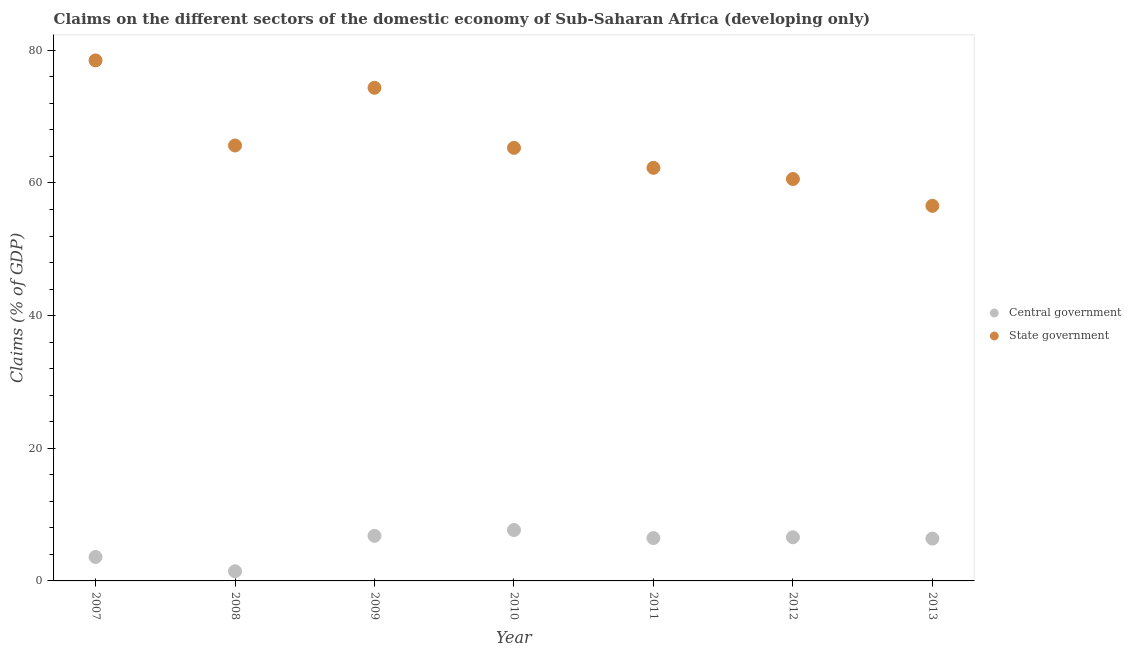What is the claims on central government in 2010?
Provide a succinct answer. 7.68. Across all years, what is the maximum claims on central government?
Ensure brevity in your answer.  7.68. Across all years, what is the minimum claims on state government?
Offer a very short reply. 56.56. In which year was the claims on central government minimum?
Offer a very short reply. 2008. What is the total claims on state government in the graph?
Make the answer very short. 463.22. What is the difference between the claims on central government in 2009 and that in 2012?
Your answer should be compact. 0.21. What is the difference between the claims on state government in 2007 and the claims on central government in 2008?
Ensure brevity in your answer.  77.03. What is the average claims on central government per year?
Offer a terse response. 5.57. In the year 2010, what is the difference between the claims on central government and claims on state government?
Provide a succinct answer. -57.62. In how many years, is the claims on state government greater than 20 %?
Provide a short and direct response. 7. What is the ratio of the claims on central government in 2008 to that in 2009?
Provide a short and direct response. 0.21. Is the claims on state government in 2009 less than that in 2013?
Give a very brief answer. No. What is the difference between the highest and the second highest claims on state government?
Give a very brief answer. 4.13. What is the difference between the highest and the lowest claims on central government?
Make the answer very short. 6.22. In how many years, is the claims on central government greater than the average claims on central government taken over all years?
Offer a terse response. 5. Is the sum of the claims on state government in 2008 and 2012 greater than the maximum claims on central government across all years?
Offer a very short reply. Yes. Is the claims on state government strictly less than the claims on central government over the years?
Provide a succinct answer. No. How many dotlines are there?
Offer a very short reply. 2. How many years are there in the graph?
Give a very brief answer. 7. Are the values on the major ticks of Y-axis written in scientific E-notation?
Keep it short and to the point. No. Does the graph contain any zero values?
Keep it short and to the point. No. Where does the legend appear in the graph?
Your response must be concise. Center right. How are the legend labels stacked?
Offer a very short reply. Vertical. What is the title of the graph?
Your answer should be very brief. Claims on the different sectors of the domestic economy of Sub-Saharan Africa (developing only). What is the label or title of the X-axis?
Provide a short and direct response. Year. What is the label or title of the Y-axis?
Offer a very short reply. Claims (% of GDP). What is the Claims (% of GDP) in Central government in 2007?
Provide a succinct answer. 3.61. What is the Claims (% of GDP) in State government in 2007?
Make the answer very short. 78.48. What is the Claims (% of GDP) of Central government in 2008?
Provide a short and direct response. 1.46. What is the Claims (% of GDP) in State government in 2008?
Give a very brief answer. 65.65. What is the Claims (% of GDP) in Central government in 2009?
Keep it short and to the point. 6.8. What is the Claims (% of GDP) in State government in 2009?
Give a very brief answer. 74.35. What is the Claims (% of GDP) in Central government in 2010?
Your response must be concise. 7.68. What is the Claims (% of GDP) in State government in 2010?
Offer a very short reply. 65.3. What is the Claims (% of GDP) of Central government in 2011?
Provide a short and direct response. 6.46. What is the Claims (% of GDP) in State government in 2011?
Your answer should be compact. 62.28. What is the Claims (% of GDP) of Central government in 2012?
Make the answer very short. 6.58. What is the Claims (% of GDP) in State government in 2012?
Provide a short and direct response. 60.59. What is the Claims (% of GDP) of Central government in 2013?
Provide a short and direct response. 6.38. What is the Claims (% of GDP) in State government in 2013?
Ensure brevity in your answer.  56.56. Across all years, what is the maximum Claims (% of GDP) of Central government?
Your response must be concise. 7.68. Across all years, what is the maximum Claims (% of GDP) of State government?
Provide a short and direct response. 78.48. Across all years, what is the minimum Claims (% of GDP) of Central government?
Offer a very short reply. 1.46. Across all years, what is the minimum Claims (% of GDP) of State government?
Your answer should be compact. 56.56. What is the total Claims (% of GDP) in Central government in the graph?
Offer a very short reply. 38.96. What is the total Claims (% of GDP) in State government in the graph?
Provide a short and direct response. 463.22. What is the difference between the Claims (% of GDP) of Central government in 2007 and that in 2008?
Your answer should be compact. 2.15. What is the difference between the Claims (% of GDP) in State government in 2007 and that in 2008?
Provide a short and direct response. 12.83. What is the difference between the Claims (% of GDP) in Central government in 2007 and that in 2009?
Provide a short and direct response. -3.19. What is the difference between the Claims (% of GDP) of State government in 2007 and that in 2009?
Your answer should be very brief. 4.13. What is the difference between the Claims (% of GDP) of Central government in 2007 and that in 2010?
Your answer should be compact. -4.07. What is the difference between the Claims (% of GDP) in State government in 2007 and that in 2010?
Keep it short and to the point. 13.18. What is the difference between the Claims (% of GDP) of Central government in 2007 and that in 2011?
Keep it short and to the point. -2.85. What is the difference between the Claims (% of GDP) of State government in 2007 and that in 2011?
Your answer should be very brief. 16.2. What is the difference between the Claims (% of GDP) of Central government in 2007 and that in 2012?
Make the answer very short. -2.97. What is the difference between the Claims (% of GDP) of State government in 2007 and that in 2012?
Provide a short and direct response. 17.89. What is the difference between the Claims (% of GDP) in Central government in 2007 and that in 2013?
Ensure brevity in your answer.  -2.77. What is the difference between the Claims (% of GDP) in State government in 2007 and that in 2013?
Provide a succinct answer. 21.92. What is the difference between the Claims (% of GDP) of Central government in 2008 and that in 2009?
Your response must be concise. -5.34. What is the difference between the Claims (% of GDP) in State government in 2008 and that in 2009?
Your answer should be very brief. -8.7. What is the difference between the Claims (% of GDP) in Central government in 2008 and that in 2010?
Give a very brief answer. -6.22. What is the difference between the Claims (% of GDP) of State government in 2008 and that in 2010?
Your answer should be very brief. 0.35. What is the difference between the Claims (% of GDP) of Central government in 2008 and that in 2011?
Ensure brevity in your answer.  -5.01. What is the difference between the Claims (% of GDP) of State government in 2008 and that in 2011?
Ensure brevity in your answer.  3.37. What is the difference between the Claims (% of GDP) of Central government in 2008 and that in 2012?
Your response must be concise. -5.13. What is the difference between the Claims (% of GDP) of State government in 2008 and that in 2012?
Offer a very short reply. 5.06. What is the difference between the Claims (% of GDP) in Central government in 2008 and that in 2013?
Your answer should be compact. -4.93. What is the difference between the Claims (% of GDP) in State government in 2008 and that in 2013?
Your answer should be compact. 9.09. What is the difference between the Claims (% of GDP) in Central government in 2009 and that in 2010?
Your response must be concise. -0.88. What is the difference between the Claims (% of GDP) of State government in 2009 and that in 2010?
Give a very brief answer. 9.06. What is the difference between the Claims (% of GDP) in Central government in 2009 and that in 2011?
Ensure brevity in your answer.  0.33. What is the difference between the Claims (% of GDP) in State government in 2009 and that in 2011?
Provide a succinct answer. 12.07. What is the difference between the Claims (% of GDP) in Central government in 2009 and that in 2012?
Provide a short and direct response. 0.21. What is the difference between the Claims (% of GDP) of State government in 2009 and that in 2012?
Offer a very short reply. 13.76. What is the difference between the Claims (% of GDP) of Central government in 2009 and that in 2013?
Your answer should be very brief. 0.41. What is the difference between the Claims (% of GDP) of State government in 2009 and that in 2013?
Offer a very short reply. 17.8. What is the difference between the Claims (% of GDP) in Central government in 2010 and that in 2011?
Your answer should be compact. 1.21. What is the difference between the Claims (% of GDP) of State government in 2010 and that in 2011?
Make the answer very short. 3.01. What is the difference between the Claims (% of GDP) in Central government in 2010 and that in 2012?
Provide a succinct answer. 1.09. What is the difference between the Claims (% of GDP) in State government in 2010 and that in 2012?
Provide a short and direct response. 4.7. What is the difference between the Claims (% of GDP) in Central government in 2010 and that in 2013?
Make the answer very short. 1.29. What is the difference between the Claims (% of GDP) of State government in 2010 and that in 2013?
Provide a short and direct response. 8.74. What is the difference between the Claims (% of GDP) of Central government in 2011 and that in 2012?
Ensure brevity in your answer.  -0.12. What is the difference between the Claims (% of GDP) in State government in 2011 and that in 2012?
Make the answer very short. 1.69. What is the difference between the Claims (% of GDP) of Central government in 2011 and that in 2013?
Offer a very short reply. 0.08. What is the difference between the Claims (% of GDP) in State government in 2011 and that in 2013?
Provide a short and direct response. 5.73. What is the difference between the Claims (% of GDP) of Central government in 2012 and that in 2013?
Ensure brevity in your answer.  0.2. What is the difference between the Claims (% of GDP) in State government in 2012 and that in 2013?
Ensure brevity in your answer.  4.04. What is the difference between the Claims (% of GDP) of Central government in 2007 and the Claims (% of GDP) of State government in 2008?
Make the answer very short. -62.04. What is the difference between the Claims (% of GDP) in Central government in 2007 and the Claims (% of GDP) in State government in 2009?
Give a very brief answer. -70.74. What is the difference between the Claims (% of GDP) in Central government in 2007 and the Claims (% of GDP) in State government in 2010?
Your answer should be compact. -61.69. What is the difference between the Claims (% of GDP) of Central government in 2007 and the Claims (% of GDP) of State government in 2011?
Your answer should be compact. -58.68. What is the difference between the Claims (% of GDP) in Central government in 2007 and the Claims (% of GDP) in State government in 2012?
Your answer should be compact. -56.98. What is the difference between the Claims (% of GDP) in Central government in 2007 and the Claims (% of GDP) in State government in 2013?
Keep it short and to the point. -52.95. What is the difference between the Claims (% of GDP) in Central government in 2008 and the Claims (% of GDP) in State government in 2009?
Ensure brevity in your answer.  -72.9. What is the difference between the Claims (% of GDP) of Central government in 2008 and the Claims (% of GDP) of State government in 2010?
Your response must be concise. -63.84. What is the difference between the Claims (% of GDP) in Central government in 2008 and the Claims (% of GDP) in State government in 2011?
Give a very brief answer. -60.83. What is the difference between the Claims (% of GDP) of Central government in 2008 and the Claims (% of GDP) of State government in 2012?
Provide a succinct answer. -59.14. What is the difference between the Claims (% of GDP) in Central government in 2008 and the Claims (% of GDP) in State government in 2013?
Your answer should be compact. -55.1. What is the difference between the Claims (% of GDP) in Central government in 2009 and the Claims (% of GDP) in State government in 2010?
Make the answer very short. -58.5. What is the difference between the Claims (% of GDP) of Central government in 2009 and the Claims (% of GDP) of State government in 2011?
Ensure brevity in your answer.  -55.49. What is the difference between the Claims (% of GDP) in Central government in 2009 and the Claims (% of GDP) in State government in 2012?
Provide a succinct answer. -53.8. What is the difference between the Claims (% of GDP) in Central government in 2009 and the Claims (% of GDP) in State government in 2013?
Your answer should be compact. -49.76. What is the difference between the Claims (% of GDP) in Central government in 2010 and the Claims (% of GDP) in State government in 2011?
Your answer should be very brief. -54.61. What is the difference between the Claims (% of GDP) in Central government in 2010 and the Claims (% of GDP) in State government in 2012?
Your response must be concise. -52.92. What is the difference between the Claims (% of GDP) of Central government in 2010 and the Claims (% of GDP) of State government in 2013?
Your answer should be compact. -48.88. What is the difference between the Claims (% of GDP) in Central government in 2011 and the Claims (% of GDP) in State government in 2012?
Provide a succinct answer. -54.13. What is the difference between the Claims (% of GDP) in Central government in 2011 and the Claims (% of GDP) in State government in 2013?
Provide a succinct answer. -50.1. What is the difference between the Claims (% of GDP) in Central government in 2012 and the Claims (% of GDP) in State government in 2013?
Your answer should be very brief. -49.97. What is the average Claims (% of GDP) in Central government per year?
Offer a very short reply. 5.57. What is the average Claims (% of GDP) of State government per year?
Provide a short and direct response. 66.17. In the year 2007, what is the difference between the Claims (% of GDP) of Central government and Claims (% of GDP) of State government?
Your response must be concise. -74.87. In the year 2008, what is the difference between the Claims (% of GDP) of Central government and Claims (% of GDP) of State government?
Give a very brief answer. -64.2. In the year 2009, what is the difference between the Claims (% of GDP) in Central government and Claims (% of GDP) in State government?
Ensure brevity in your answer.  -67.56. In the year 2010, what is the difference between the Claims (% of GDP) of Central government and Claims (% of GDP) of State government?
Ensure brevity in your answer.  -57.62. In the year 2011, what is the difference between the Claims (% of GDP) of Central government and Claims (% of GDP) of State government?
Give a very brief answer. -55.82. In the year 2012, what is the difference between the Claims (% of GDP) in Central government and Claims (% of GDP) in State government?
Keep it short and to the point. -54.01. In the year 2013, what is the difference between the Claims (% of GDP) of Central government and Claims (% of GDP) of State government?
Your answer should be compact. -50.17. What is the ratio of the Claims (% of GDP) in Central government in 2007 to that in 2008?
Ensure brevity in your answer.  2.48. What is the ratio of the Claims (% of GDP) in State government in 2007 to that in 2008?
Provide a succinct answer. 1.2. What is the ratio of the Claims (% of GDP) in Central government in 2007 to that in 2009?
Give a very brief answer. 0.53. What is the ratio of the Claims (% of GDP) of State government in 2007 to that in 2009?
Your response must be concise. 1.06. What is the ratio of the Claims (% of GDP) of Central government in 2007 to that in 2010?
Offer a terse response. 0.47. What is the ratio of the Claims (% of GDP) in State government in 2007 to that in 2010?
Offer a terse response. 1.2. What is the ratio of the Claims (% of GDP) of Central government in 2007 to that in 2011?
Give a very brief answer. 0.56. What is the ratio of the Claims (% of GDP) in State government in 2007 to that in 2011?
Your answer should be compact. 1.26. What is the ratio of the Claims (% of GDP) of Central government in 2007 to that in 2012?
Provide a succinct answer. 0.55. What is the ratio of the Claims (% of GDP) in State government in 2007 to that in 2012?
Make the answer very short. 1.3. What is the ratio of the Claims (% of GDP) in Central government in 2007 to that in 2013?
Your answer should be very brief. 0.57. What is the ratio of the Claims (% of GDP) in State government in 2007 to that in 2013?
Provide a short and direct response. 1.39. What is the ratio of the Claims (% of GDP) of Central government in 2008 to that in 2009?
Ensure brevity in your answer.  0.21. What is the ratio of the Claims (% of GDP) of State government in 2008 to that in 2009?
Give a very brief answer. 0.88. What is the ratio of the Claims (% of GDP) of Central government in 2008 to that in 2010?
Give a very brief answer. 0.19. What is the ratio of the Claims (% of GDP) of State government in 2008 to that in 2010?
Keep it short and to the point. 1.01. What is the ratio of the Claims (% of GDP) in Central government in 2008 to that in 2011?
Make the answer very short. 0.23. What is the ratio of the Claims (% of GDP) of State government in 2008 to that in 2011?
Your response must be concise. 1.05. What is the ratio of the Claims (% of GDP) of Central government in 2008 to that in 2012?
Your answer should be very brief. 0.22. What is the ratio of the Claims (% of GDP) of State government in 2008 to that in 2012?
Your response must be concise. 1.08. What is the ratio of the Claims (% of GDP) of Central government in 2008 to that in 2013?
Offer a very short reply. 0.23. What is the ratio of the Claims (% of GDP) in State government in 2008 to that in 2013?
Provide a succinct answer. 1.16. What is the ratio of the Claims (% of GDP) in Central government in 2009 to that in 2010?
Give a very brief answer. 0.89. What is the ratio of the Claims (% of GDP) in State government in 2009 to that in 2010?
Offer a terse response. 1.14. What is the ratio of the Claims (% of GDP) in Central government in 2009 to that in 2011?
Offer a terse response. 1.05. What is the ratio of the Claims (% of GDP) of State government in 2009 to that in 2011?
Offer a terse response. 1.19. What is the ratio of the Claims (% of GDP) in Central government in 2009 to that in 2012?
Offer a very short reply. 1.03. What is the ratio of the Claims (% of GDP) in State government in 2009 to that in 2012?
Your answer should be compact. 1.23. What is the ratio of the Claims (% of GDP) of Central government in 2009 to that in 2013?
Offer a very short reply. 1.06. What is the ratio of the Claims (% of GDP) in State government in 2009 to that in 2013?
Ensure brevity in your answer.  1.31. What is the ratio of the Claims (% of GDP) of Central government in 2010 to that in 2011?
Your answer should be very brief. 1.19. What is the ratio of the Claims (% of GDP) in State government in 2010 to that in 2011?
Give a very brief answer. 1.05. What is the ratio of the Claims (% of GDP) in Central government in 2010 to that in 2012?
Offer a very short reply. 1.17. What is the ratio of the Claims (% of GDP) of State government in 2010 to that in 2012?
Make the answer very short. 1.08. What is the ratio of the Claims (% of GDP) in Central government in 2010 to that in 2013?
Your answer should be compact. 1.2. What is the ratio of the Claims (% of GDP) in State government in 2010 to that in 2013?
Offer a very short reply. 1.15. What is the ratio of the Claims (% of GDP) of Central government in 2011 to that in 2012?
Make the answer very short. 0.98. What is the ratio of the Claims (% of GDP) in State government in 2011 to that in 2012?
Offer a terse response. 1.03. What is the ratio of the Claims (% of GDP) of Central government in 2011 to that in 2013?
Your response must be concise. 1.01. What is the ratio of the Claims (% of GDP) in State government in 2011 to that in 2013?
Your response must be concise. 1.1. What is the ratio of the Claims (% of GDP) of Central government in 2012 to that in 2013?
Provide a short and direct response. 1.03. What is the ratio of the Claims (% of GDP) in State government in 2012 to that in 2013?
Give a very brief answer. 1.07. What is the difference between the highest and the second highest Claims (% of GDP) in Central government?
Offer a terse response. 0.88. What is the difference between the highest and the second highest Claims (% of GDP) of State government?
Your answer should be compact. 4.13. What is the difference between the highest and the lowest Claims (% of GDP) of Central government?
Offer a terse response. 6.22. What is the difference between the highest and the lowest Claims (% of GDP) in State government?
Ensure brevity in your answer.  21.92. 